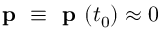<formula> <loc_0><loc_0><loc_500><loc_500>p \equiv p ( t _ { 0 } ) \approx 0</formula> 